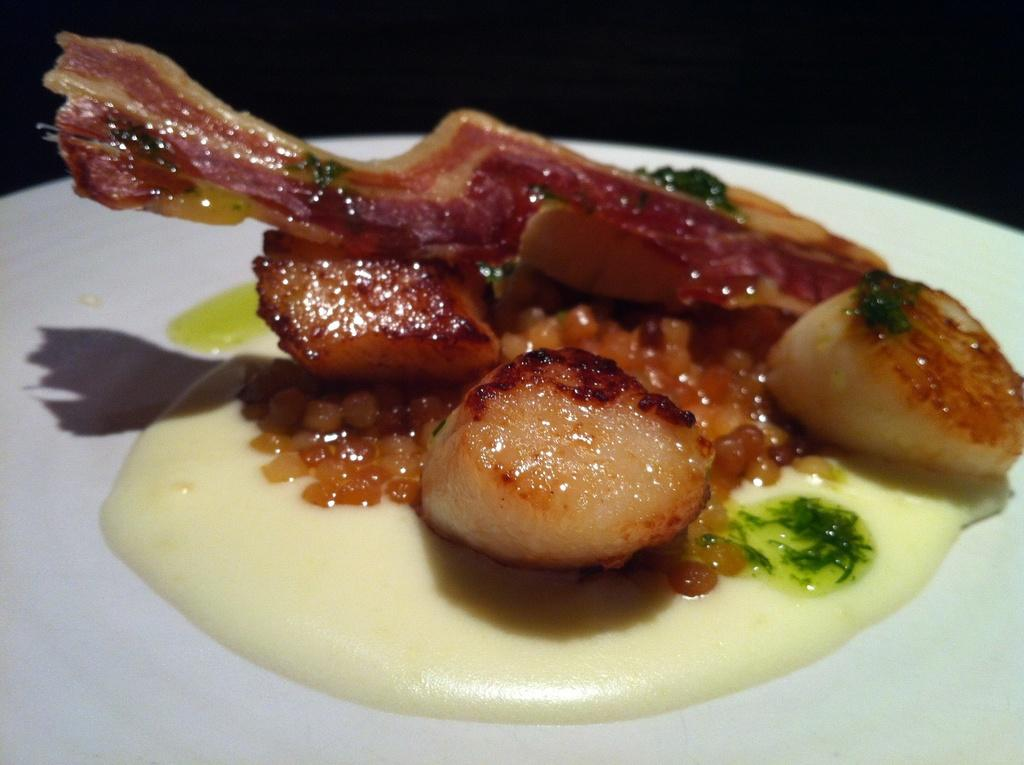What is on the plate that is visible in the image? There is food on a plate in the image. What color is the plate? The plate is white. What type of wood is used to make the jelly in the image? There is no jelly or wood present in the image; it only features food on a white plate. 